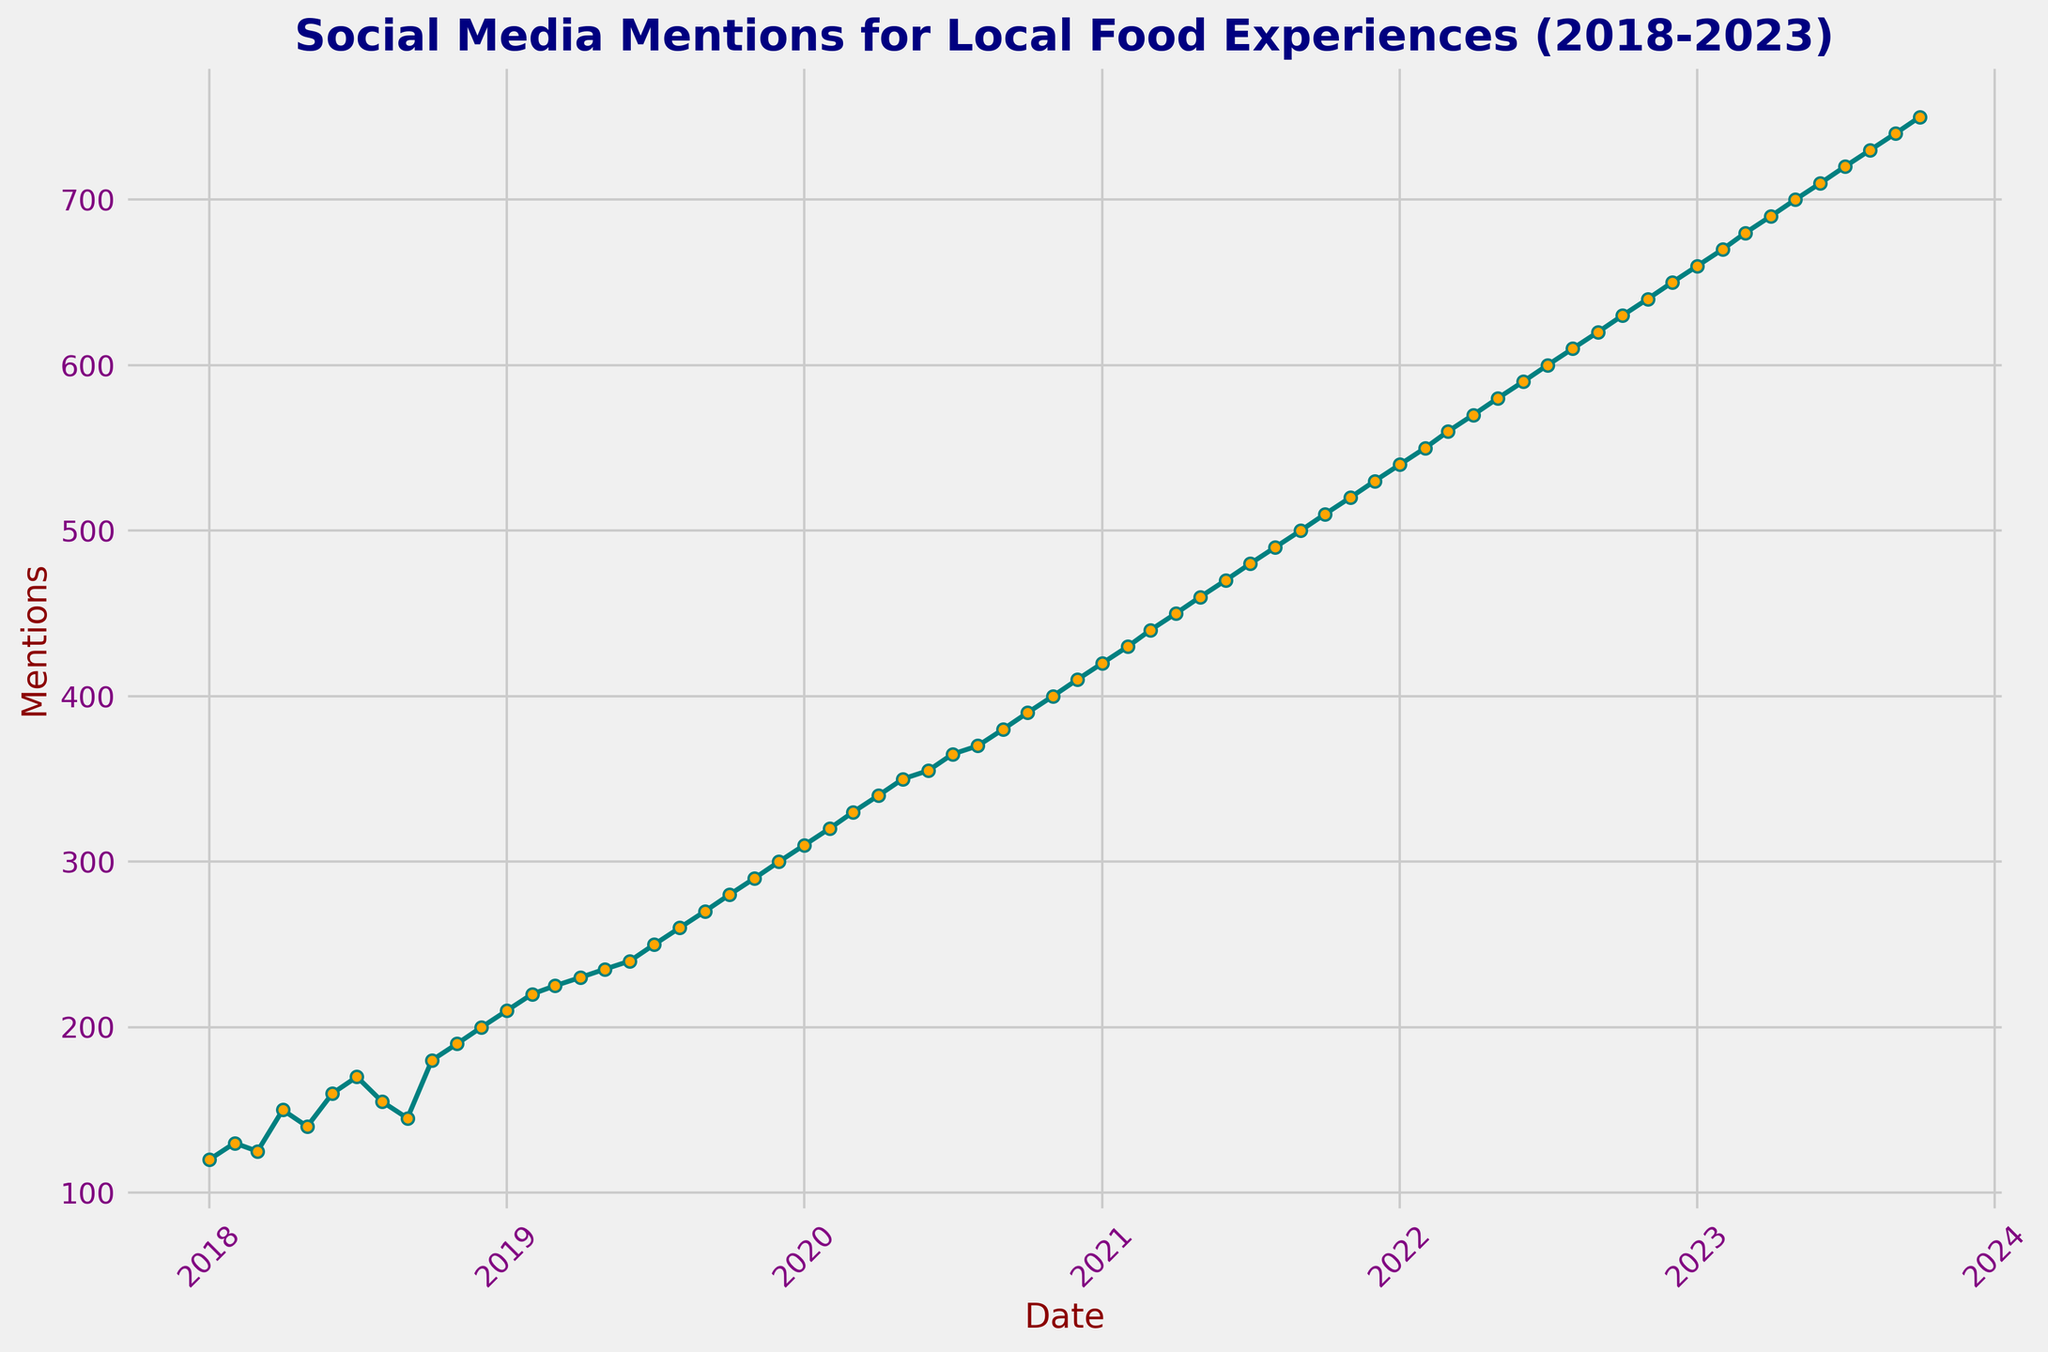What's the overall trend of social media mentions from 2018 to 2023? The overall trend of social media mentions shows a continuous increase from 2018 to 2023, indicating a growing interest in local food experiences over the years.
Answer: Continuous increase Which year had the biggest jump in social media mentions compared to the previous year? To identify the biggest jump, we compare the yearly increases: from 2018 to 2019, there was an increase of 100 mentions; from 2019 to 2020, the increase was 110 mentions; from 2020 to 2021, the increase was also 110 mentions; from 2021 to 2022, it was 110 mentions; and from 2022 to 2023, the increase is also 110 mentions. Thus, the year 2020 had the biggest jump compared to the previous year.
Answer: 2020 What is the average number of social media mentions per month in the year 2022? To compute the average number of social media mentions per month in 2022, sum up the mentions from Jan to Dec 2022: (540 + 550 + 560 + 570 + 580 + 590 + 600 + 610 + 620 + 630 + 640 + 650) = 7140. Then, divide by 12 months: 7140 / 12 = 595.
Answer: 595 In which months do social media mentions cross the 500 mark for the first time? The first time social media mentions cross the 500 mark is in Sep 2021 when the mentions reached 500.
Answer: Sep 2021 Compare the social media mentions in June for each year. Which year saw the highest mentions and which saw the lowest? The social media mentions for June are: 2018: 160, 2019: 240, 2020: 355, 2021: 470, 2022: 590, 2023: 710. The highest mentions are in June 2023 (710), and the lowest are in June 2018 (160).
Answer: Highest: June 2023, Lowest: June 2018 What is the average annual growth in social media mentions from 2018 to 2023? To find the average annual growth, calculate the total increase from 2018 to 2023 and divide by the number of years: 750 (Oct 2023) - 120 (Jan 2018) = 630 mentions over 5.75 years. Average growth per year = 630 / 5.75 ≈ 109.57.
Answer: ≈ 109.57 How many times did the number of social media mentions fall from one month to the next within the same year? By inspecting the trend within each year: 
2018 (from Aug to Sep, and from Sep to Oct),
2019 (no fall),
2020 (no fall),
2021 (no fall),
2022 (no fall),
2023 (no fall).
The number of falls: 2 times only in 2018.
Answer: 2 times 